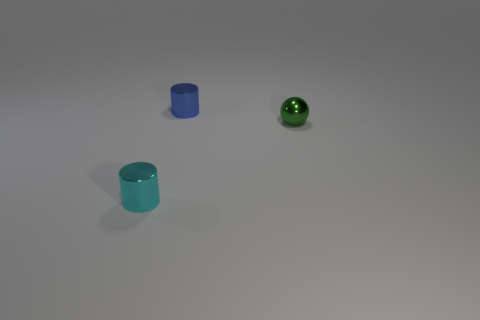Add 2 purple rubber blocks. How many objects exist? 5 Subtract all cylinders. How many objects are left? 1 Subtract 1 green balls. How many objects are left? 2 Subtract all large red blocks. Subtract all balls. How many objects are left? 2 Add 3 small shiny things. How many small shiny things are left? 6 Add 3 tiny green metallic blocks. How many tiny green metallic blocks exist? 3 